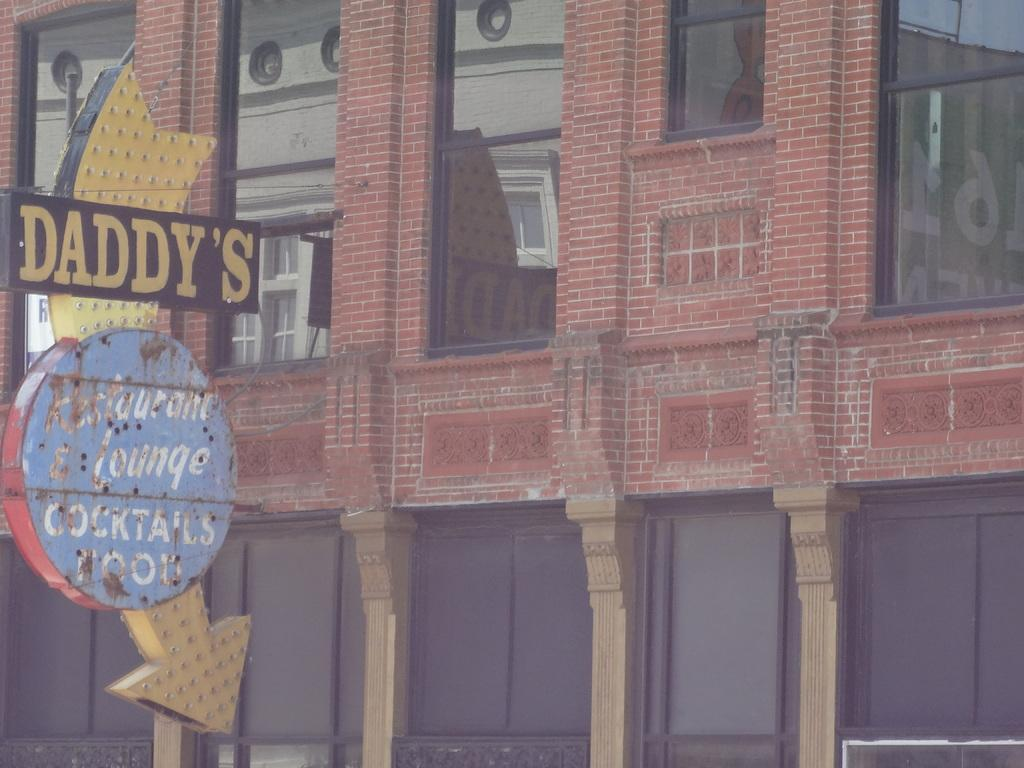What is the main structure in the image? There is a building in the image. What can be seen on the left side of the image? There is a board on the left side of the image. What feature is present in the building? There are windows in the building. Can you see a yak grazing near the building in the image? There is no yak present in the image. How many kisses are exchanged between the people in the image? There are no people present in the image, so no kisses can be observed. 